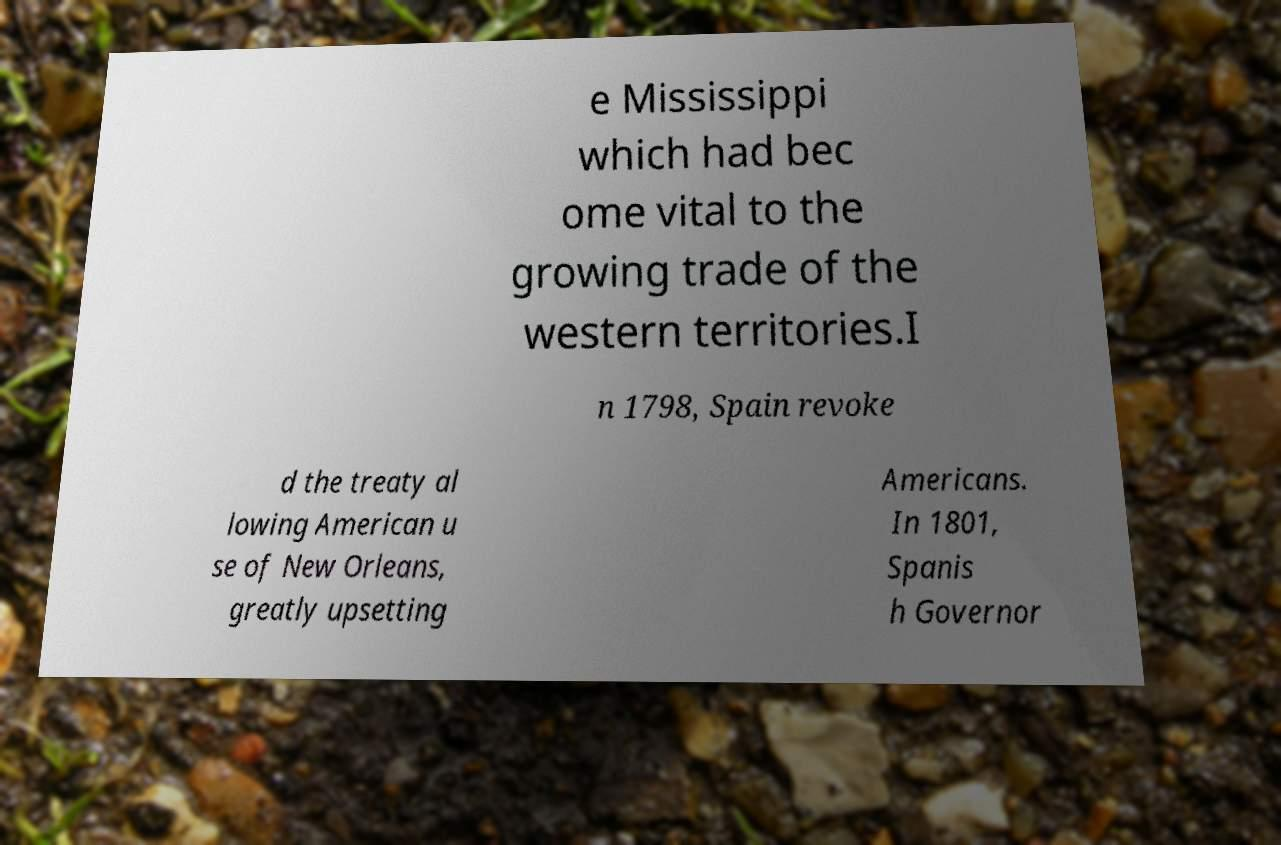There's text embedded in this image that I need extracted. Can you transcribe it verbatim? e Mississippi which had bec ome vital to the growing trade of the western territories.I n 1798, Spain revoke d the treaty al lowing American u se of New Orleans, greatly upsetting Americans. In 1801, Spanis h Governor 